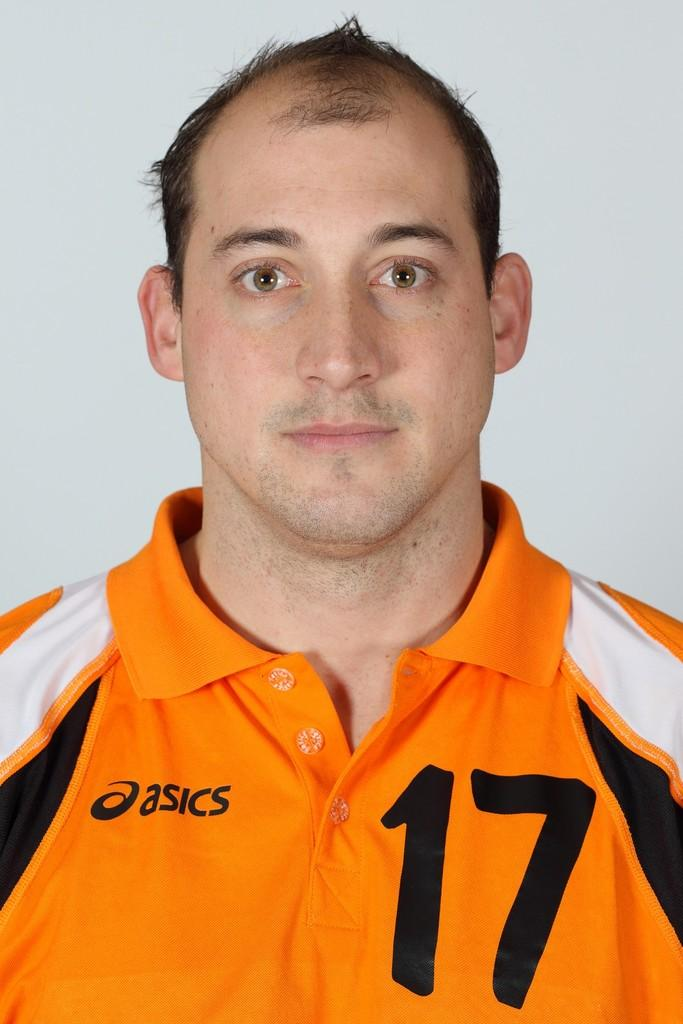<image>
Share a concise interpretation of the image provided. A man wearing an Asics polo shirt with the number 17 on it poses for a photo. 